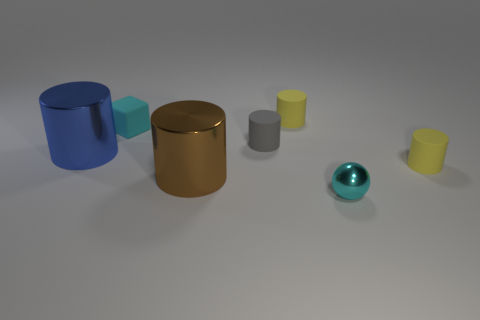Is there a tiny yellow object made of the same material as the cyan sphere?
Your answer should be compact. No. Is the size of the cyan object behind the blue metal cylinder the same as the large blue metallic cylinder?
Your answer should be compact. No. There is a yellow object that is behind the large cylinder on the left side of the cyan cube; are there any small cylinders that are on the right side of it?
Offer a terse response. Yes. What number of metal things are large red cubes or brown things?
Provide a succinct answer. 1. What number of other objects are there of the same shape as the blue thing?
Your answer should be very brief. 4. Is the number of large blue matte cylinders greater than the number of big blue cylinders?
Your answer should be very brief. No. How big is the metal object behind the yellow matte cylinder to the right of the tiny yellow rubber thing that is on the left side of the small sphere?
Offer a very short reply. Large. There is a yellow cylinder behind the gray rubber cylinder; what size is it?
Provide a short and direct response. Small. What number of things are purple rubber blocks or objects in front of the big brown metallic cylinder?
Keep it short and to the point. 1. What number of other things are the same size as the gray matte thing?
Your answer should be very brief. 4. 